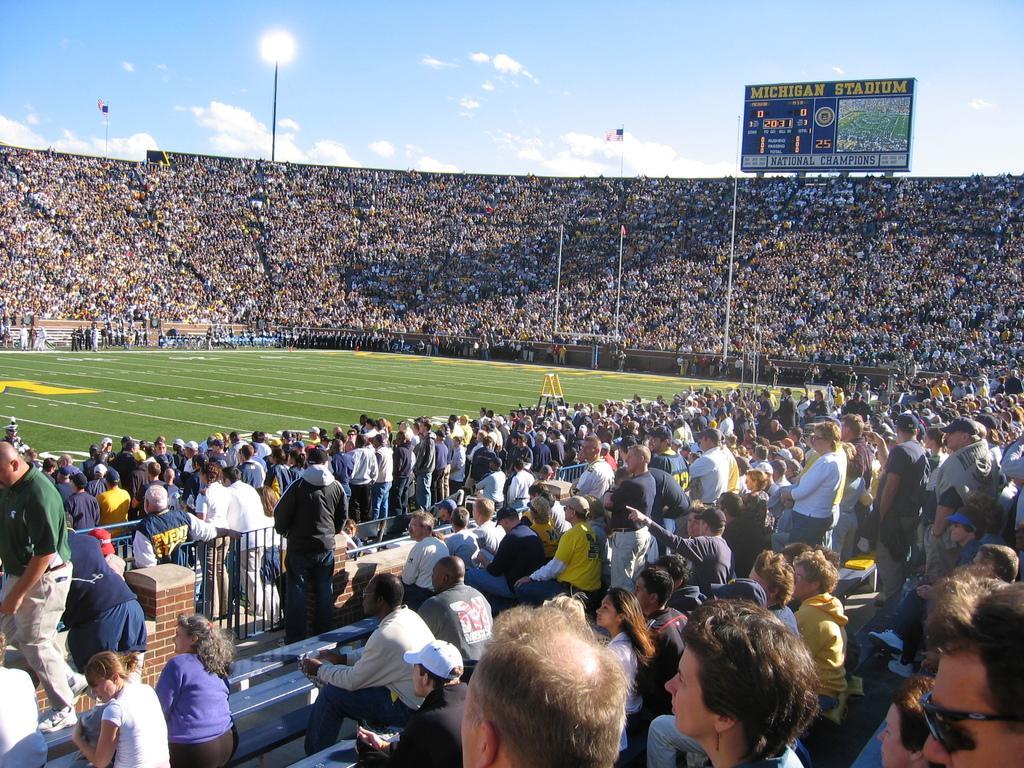How would you summarize this image in a sentence or two? In this image, I can see a stadium with groups of people standing and groups of people sitting. There are two flags hanging to the poles, a light pole and a hoarding. At the bottom of the image, I can see the iron grilles and benches. In the background, there is the sky. 